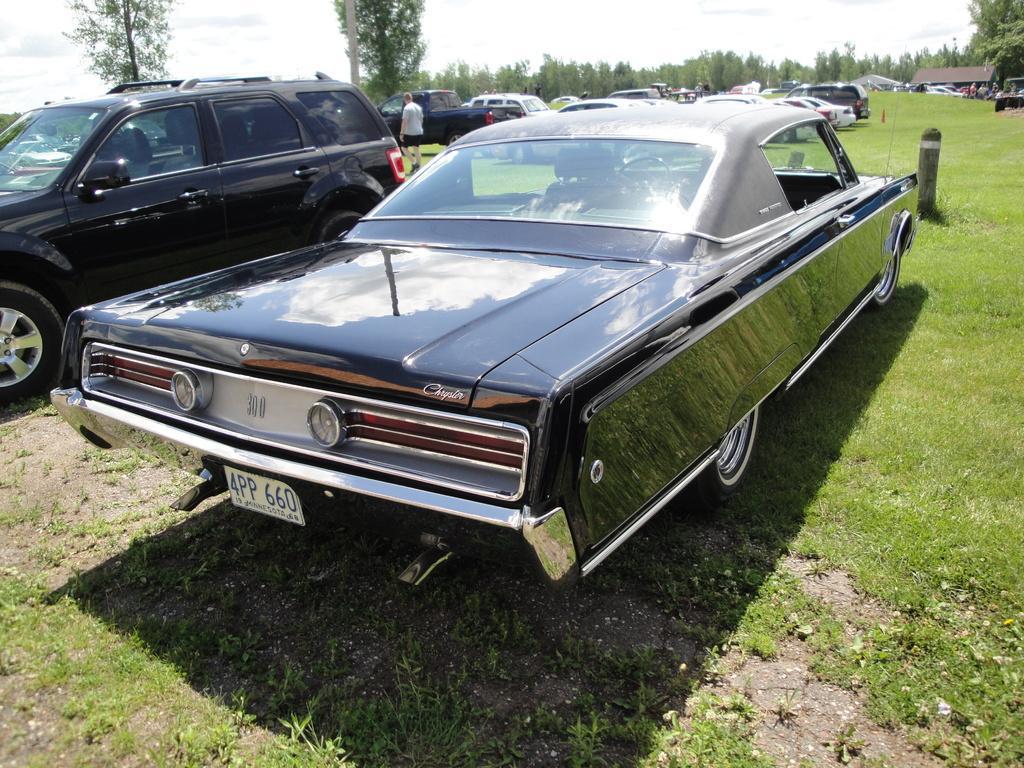In one or two sentences, can you explain what this image depicts? In this image I can see few vehicles. In front the vehicle is in black color, background I can see the person walking and the person is wearing white shirt, black short and I can see trees in green color and the sky is in white color. 